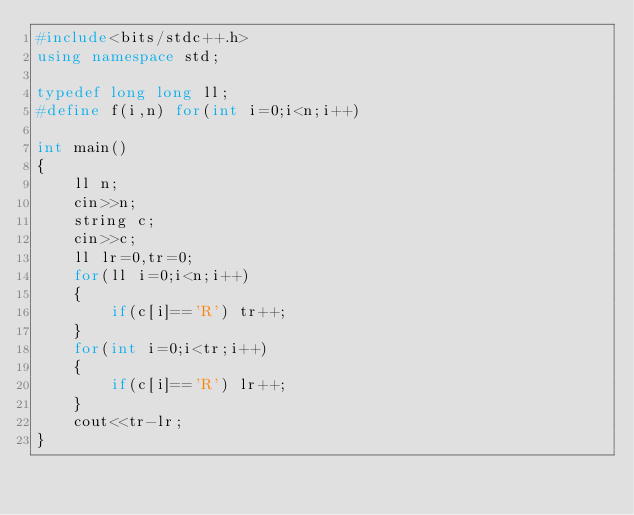Convert code to text. <code><loc_0><loc_0><loc_500><loc_500><_C++_>#include<bits/stdc++.h>
using namespace std;

typedef long long ll;
#define f(i,n) for(int i=0;i<n;i++)

int main()
{
    ll n;
    cin>>n;
    string c;
    cin>>c;
    ll lr=0,tr=0;
    for(ll i=0;i<n;i++)
    {
        if(c[i]=='R') tr++;
    }
    for(int i=0;i<tr;i++)
    {
        if(c[i]=='R') lr++;
    }
    cout<<tr-lr;
}</code> 